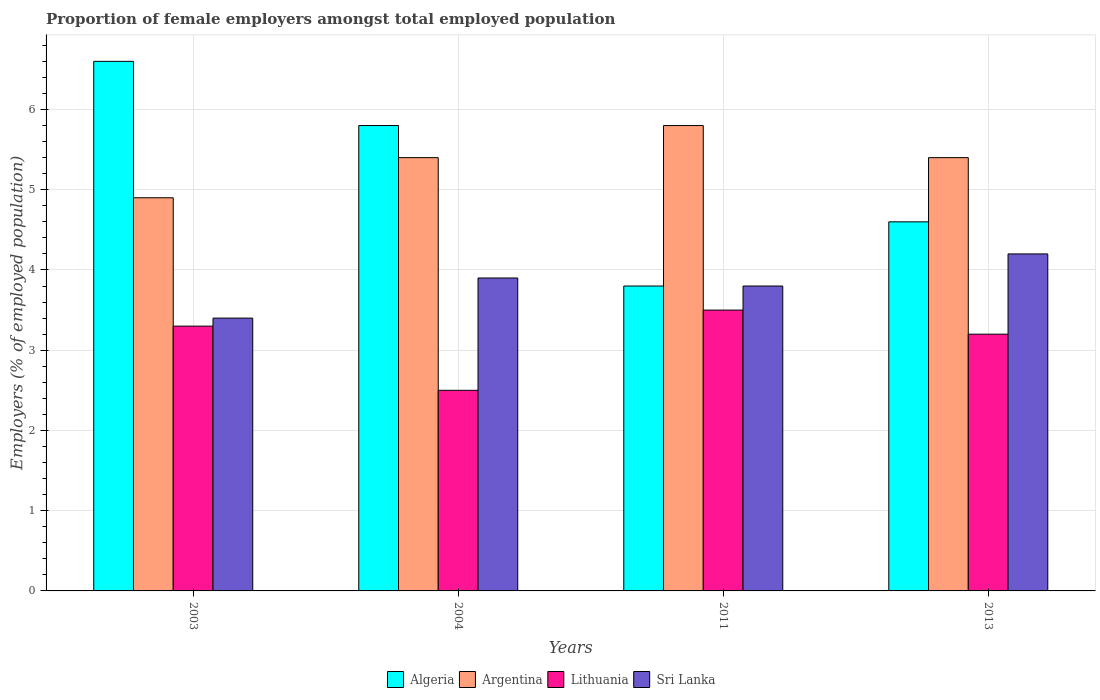How many different coloured bars are there?
Ensure brevity in your answer.  4. How many groups of bars are there?
Keep it short and to the point. 4. Are the number of bars per tick equal to the number of legend labels?
Your answer should be very brief. Yes. How many bars are there on the 4th tick from the left?
Give a very brief answer. 4. What is the label of the 4th group of bars from the left?
Your response must be concise. 2013. What is the proportion of female employers in Lithuania in 2011?
Give a very brief answer. 3.5. Across all years, what is the maximum proportion of female employers in Lithuania?
Make the answer very short. 3.5. Across all years, what is the minimum proportion of female employers in Argentina?
Give a very brief answer. 4.9. In which year was the proportion of female employers in Lithuania maximum?
Ensure brevity in your answer.  2011. In which year was the proportion of female employers in Sri Lanka minimum?
Offer a terse response. 2003. What is the total proportion of female employers in Algeria in the graph?
Your response must be concise. 20.8. What is the difference between the proportion of female employers in Lithuania in 2003 and that in 2004?
Ensure brevity in your answer.  0.8. What is the difference between the proportion of female employers in Lithuania in 2013 and the proportion of female employers in Algeria in 2004?
Make the answer very short. -2.6. What is the average proportion of female employers in Argentina per year?
Your answer should be compact. 5.38. In how many years, is the proportion of female employers in Algeria greater than 5 %?
Provide a short and direct response. 2. What is the ratio of the proportion of female employers in Sri Lanka in 2004 to that in 2011?
Your answer should be compact. 1.03. Is the proportion of female employers in Argentina in 2003 less than that in 2013?
Make the answer very short. Yes. Is the difference between the proportion of female employers in Sri Lanka in 2003 and 2013 greater than the difference between the proportion of female employers in Argentina in 2003 and 2013?
Offer a terse response. No. What is the difference between the highest and the second highest proportion of female employers in Algeria?
Provide a short and direct response. 0.8. Is the sum of the proportion of female employers in Sri Lanka in 2004 and 2013 greater than the maximum proportion of female employers in Argentina across all years?
Your answer should be very brief. Yes. Is it the case that in every year, the sum of the proportion of female employers in Argentina and proportion of female employers in Sri Lanka is greater than the sum of proportion of female employers in Algeria and proportion of female employers in Lithuania?
Provide a short and direct response. No. What does the 4th bar from the left in 2013 represents?
Your response must be concise. Sri Lanka. What does the 3rd bar from the right in 2011 represents?
Offer a terse response. Argentina. How many bars are there?
Give a very brief answer. 16. How many years are there in the graph?
Offer a terse response. 4. Are the values on the major ticks of Y-axis written in scientific E-notation?
Offer a terse response. No. Does the graph contain any zero values?
Give a very brief answer. No. Does the graph contain grids?
Offer a very short reply. Yes. Where does the legend appear in the graph?
Provide a succinct answer. Bottom center. How many legend labels are there?
Give a very brief answer. 4. How are the legend labels stacked?
Offer a very short reply. Horizontal. What is the title of the graph?
Give a very brief answer. Proportion of female employers amongst total employed population. What is the label or title of the X-axis?
Your answer should be compact. Years. What is the label or title of the Y-axis?
Give a very brief answer. Employers (% of employed population). What is the Employers (% of employed population) of Algeria in 2003?
Give a very brief answer. 6.6. What is the Employers (% of employed population) in Argentina in 2003?
Ensure brevity in your answer.  4.9. What is the Employers (% of employed population) in Lithuania in 2003?
Provide a short and direct response. 3.3. What is the Employers (% of employed population) in Sri Lanka in 2003?
Make the answer very short. 3.4. What is the Employers (% of employed population) of Algeria in 2004?
Keep it short and to the point. 5.8. What is the Employers (% of employed population) in Argentina in 2004?
Provide a succinct answer. 5.4. What is the Employers (% of employed population) in Sri Lanka in 2004?
Offer a very short reply. 3.9. What is the Employers (% of employed population) of Algeria in 2011?
Your answer should be very brief. 3.8. What is the Employers (% of employed population) of Argentina in 2011?
Provide a succinct answer. 5.8. What is the Employers (% of employed population) of Lithuania in 2011?
Your answer should be compact. 3.5. What is the Employers (% of employed population) of Sri Lanka in 2011?
Offer a terse response. 3.8. What is the Employers (% of employed population) of Algeria in 2013?
Your answer should be compact. 4.6. What is the Employers (% of employed population) in Argentina in 2013?
Ensure brevity in your answer.  5.4. What is the Employers (% of employed population) in Lithuania in 2013?
Offer a terse response. 3.2. What is the Employers (% of employed population) of Sri Lanka in 2013?
Provide a succinct answer. 4.2. Across all years, what is the maximum Employers (% of employed population) in Algeria?
Provide a succinct answer. 6.6. Across all years, what is the maximum Employers (% of employed population) of Argentina?
Offer a very short reply. 5.8. Across all years, what is the maximum Employers (% of employed population) in Sri Lanka?
Provide a succinct answer. 4.2. Across all years, what is the minimum Employers (% of employed population) of Algeria?
Your answer should be compact. 3.8. Across all years, what is the minimum Employers (% of employed population) in Argentina?
Your answer should be very brief. 4.9. Across all years, what is the minimum Employers (% of employed population) of Sri Lanka?
Keep it short and to the point. 3.4. What is the total Employers (% of employed population) of Algeria in the graph?
Offer a terse response. 20.8. What is the total Employers (% of employed population) of Lithuania in the graph?
Give a very brief answer. 12.5. What is the total Employers (% of employed population) of Sri Lanka in the graph?
Offer a very short reply. 15.3. What is the difference between the Employers (% of employed population) of Algeria in 2003 and that in 2004?
Offer a very short reply. 0.8. What is the difference between the Employers (% of employed population) in Argentina in 2003 and that in 2004?
Your response must be concise. -0.5. What is the difference between the Employers (% of employed population) of Lithuania in 2003 and that in 2004?
Offer a very short reply. 0.8. What is the difference between the Employers (% of employed population) in Algeria in 2003 and that in 2011?
Provide a succinct answer. 2.8. What is the difference between the Employers (% of employed population) in Lithuania in 2003 and that in 2011?
Provide a succinct answer. -0.2. What is the difference between the Employers (% of employed population) in Sri Lanka in 2003 and that in 2011?
Provide a short and direct response. -0.4. What is the difference between the Employers (% of employed population) of Algeria in 2003 and that in 2013?
Your response must be concise. 2. What is the difference between the Employers (% of employed population) of Argentina in 2003 and that in 2013?
Your answer should be very brief. -0.5. What is the difference between the Employers (% of employed population) in Argentina in 2004 and that in 2011?
Give a very brief answer. -0.4. What is the difference between the Employers (% of employed population) of Lithuania in 2004 and that in 2011?
Offer a very short reply. -1. What is the difference between the Employers (% of employed population) in Argentina in 2004 and that in 2013?
Keep it short and to the point. 0. What is the difference between the Employers (% of employed population) of Algeria in 2003 and the Employers (% of employed population) of Argentina in 2004?
Offer a very short reply. 1.2. What is the difference between the Employers (% of employed population) of Algeria in 2003 and the Employers (% of employed population) of Sri Lanka in 2004?
Make the answer very short. 2.7. What is the difference between the Employers (% of employed population) of Argentina in 2003 and the Employers (% of employed population) of Lithuania in 2004?
Provide a succinct answer. 2.4. What is the difference between the Employers (% of employed population) in Argentina in 2003 and the Employers (% of employed population) in Sri Lanka in 2004?
Offer a very short reply. 1. What is the difference between the Employers (% of employed population) in Algeria in 2003 and the Employers (% of employed population) in Lithuania in 2011?
Offer a terse response. 3.1. What is the difference between the Employers (% of employed population) of Algeria in 2003 and the Employers (% of employed population) of Sri Lanka in 2011?
Your answer should be very brief. 2.8. What is the difference between the Employers (% of employed population) of Argentina in 2003 and the Employers (% of employed population) of Lithuania in 2011?
Give a very brief answer. 1.4. What is the difference between the Employers (% of employed population) in Argentina in 2003 and the Employers (% of employed population) in Sri Lanka in 2011?
Give a very brief answer. 1.1. What is the difference between the Employers (% of employed population) in Algeria in 2003 and the Employers (% of employed population) in Lithuania in 2013?
Make the answer very short. 3.4. What is the difference between the Employers (% of employed population) in Argentina in 2003 and the Employers (% of employed population) in Sri Lanka in 2013?
Provide a short and direct response. 0.7. What is the difference between the Employers (% of employed population) of Algeria in 2004 and the Employers (% of employed population) of Argentina in 2011?
Provide a short and direct response. 0. What is the difference between the Employers (% of employed population) of Algeria in 2004 and the Employers (% of employed population) of Lithuania in 2011?
Give a very brief answer. 2.3. What is the difference between the Employers (% of employed population) in Algeria in 2004 and the Employers (% of employed population) in Sri Lanka in 2011?
Keep it short and to the point. 2. What is the difference between the Employers (% of employed population) in Argentina in 2004 and the Employers (% of employed population) in Lithuania in 2011?
Provide a succinct answer. 1.9. What is the difference between the Employers (% of employed population) in Algeria in 2004 and the Employers (% of employed population) in Argentina in 2013?
Offer a very short reply. 0.4. What is the difference between the Employers (% of employed population) of Algeria in 2004 and the Employers (% of employed population) of Lithuania in 2013?
Ensure brevity in your answer.  2.6. What is the difference between the Employers (% of employed population) in Algeria in 2004 and the Employers (% of employed population) in Sri Lanka in 2013?
Offer a terse response. 1.6. What is the difference between the Employers (% of employed population) of Argentina in 2004 and the Employers (% of employed population) of Lithuania in 2013?
Ensure brevity in your answer.  2.2. What is the difference between the Employers (% of employed population) of Algeria in 2011 and the Employers (% of employed population) of Argentina in 2013?
Your answer should be very brief. -1.6. What is the difference between the Employers (% of employed population) in Algeria in 2011 and the Employers (% of employed population) in Sri Lanka in 2013?
Make the answer very short. -0.4. What is the average Employers (% of employed population) in Argentina per year?
Your answer should be compact. 5.38. What is the average Employers (% of employed population) in Lithuania per year?
Give a very brief answer. 3.12. What is the average Employers (% of employed population) in Sri Lanka per year?
Your answer should be very brief. 3.83. In the year 2003, what is the difference between the Employers (% of employed population) of Algeria and Employers (% of employed population) of Lithuania?
Make the answer very short. 3.3. In the year 2003, what is the difference between the Employers (% of employed population) in Algeria and Employers (% of employed population) in Sri Lanka?
Give a very brief answer. 3.2. In the year 2003, what is the difference between the Employers (% of employed population) in Lithuania and Employers (% of employed population) in Sri Lanka?
Provide a succinct answer. -0.1. In the year 2004, what is the difference between the Employers (% of employed population) in Algeria and Employers (% of employed population) in Argentina?
Provide a short and direct response. 0.4. In the year 2004, what is the difference between the Employers (% of employed population) of Algeria and Employers (% of employed population) of Lithuania?
Your answer should be compact. 3.3. In the year 2004, what is the difference between the Employers (% of employed population) of Algeria and Employers (% of employed population) of Sri Lanka?
Give a very brief answer. 1.9. In the year 2004, what is the difference between the Employers (% of employed population) in Lithuania and Employers (% of employed population) in Sri Lanka?
Provide a short and direct response. -1.4. In the year 2011, what is the difference between the Employers (% of employed population) in Algeria and Employers (% of employed population) in Argentina?
Your response must be concise. -2. In the year 2011, what is the difference between the Employers (% of employed population) of Algeria and Employers (% of employed population) of Lithuania?
Your answer should be compact. 0.3. In the year 2011, what is the difference between the Employers (% of employed population) in Algeria and Employers (% of employed population) in Sri Lanka?
Provide a succinct answer. 0. In the year 2011, what is the difference between the Employers (% of employed population) in Argentina and Employers (% of employed population) in Lithuania?
Ensure brevity in your answer.  2.3. In the year 2011, what is the difference between the Employers (% of employed population) of Argentina and Employers (% of employed population) of Sri Lanka?
Keep it short and to the point. 2. In the year 2011, what is the difference between the Employers (% of employed population) in Lithuania and Employers (% of employed population) in Sri Lanka?
Offer a terse response. -0.3. In the year 2013, what is the difference between the Employers (% of employed population) of Algeria and Employers (% of employed population) of Argentina?
Your answer should be compact. -0.8. In the year 2013, what is the difference between the Employers (% of employed population) of Algeria and Employers (% of employed population) of Lithuania?
Keep it short and to the point. 1.4. In the year 2013, what is the difference between the Employers (% of employed population) of Lithuania and Employers (% of employed population) of Sri Lanka?
Provide a short and direct response. -1. What is the ratio of the Employers (% of employed population) in Algeria in 2003 to that in 2004?
Provide a short and direct response. 1.14. What is the ratio of the Employers (% of employed population) in Argentina in 2003 to that in 2004?
Your answer should be compact. 0.91. What is the ratio of the Employers (% of employed population) in Lithuania in 2003 to that in 2004?
Ensure brevity in your answer.  1.32. What is the ratio of the Employers (% of employed population) of Sri Lanka in 2003 to that in 2004?
Your answer should be compact. 0.87. What is the ratio of the Employers (% of employed population) in Algeria in 2003 to that in 2011?
Your response must be concise. 1.74. What is the ratio of the Employers (% of employed population) in Argentina in 2003 to that in 2011?
Provide a succinct answer. 0.84. What is the ratio of the Employers (% of employed population) of Lithuania in 2003 to that in 2011?
Your answer should be very brief. 0.94. What is the ratio of the Employers (% of employed population) in Sri Lanka in 2003 to that in 2011?
Provide a short and direct response. 0.89. What is the ratio of the Employers (% of employed population) in Algeria in 2003 to that in 2013?
Make the answer very short. 1.43. What is the ratio of the Employers (% of employed population) in Argentina in 2003 to that in 2013?
Your response must be concise. 0.91. What is the ratio of the Employers (% of employed population) in Lithuania in 2003 to that in 2013?
Offer a very short reply. 1.03. What is the ratio of the Employers (% of employed population) of Sri Lanka in 2003 to that in 2013?
Offer a terse response. 0.81. What is the ratio of the Employers (% of employed population) in Algeria in 2004 to that in 2011?
Provide a succinct answer. 1.53. What is the ratio of the Employers (% of employed population) of Argentina in 2004 to that in 2011?
Make the answer very short. 0.93. What is the ratio of the Employers (% of employed population) of Lithuania in 2004 to that in 2011?
Provide a succinct answer. 0.71. What is the ratio of the Employers (% of employed population) in Sri Lanka in 2004 to that in 2011?
Make the answer very short. 1.03. What is the ratio of the Employers (% of employed population) in Algeria in 2004 to that in 2013?
Make the answer very short. 1.26. What is the ratio of the Employers (% of employed population) in Argentina in 2004 to that in 2013?
Ensure brevity in your answer.  1. What is the ratio of the Employers (% of employed population) in Lithuania in 2004 to that in 2013?
Make the answer very short. 0.78. What is the ratio of the Employers (% of employed population) in Sri Lanka in 2004 to that in 2013?
Your answer should be very brief. 0.93. What is the ratio of the Employers (% of employed population) of Algeria in 2011 to that in 2013?
Keep it short and to the point. 0.83. What is the ratio of the Employers (% of employed population) of Argentina in 2011 to that in 2013?
Offer a terse response. 1.07. What is the ratio of the Employers (% of employed population) of Lithuania in 2011 to that in 2013?
Your response must be concise. 1.09. What is the ratio of the Employers (% of employed population) of Sri Lanka in 2011 to that in 2013?
Provide a short and direct response. 0.9. What is the difference between the highest and the second highest Employers (% of employed population) in Algeria?
Offer a very short reply. 0.8. What is the difference between the highest and the second highest Employers (% of employed population) in Argentina?
Your response must be concise. 0.4. What is the difference between the highest and the second highest Employers (% of employed population) of Lithuania?
Give a very brief answer. 0.2. What is the difference between the highest and the lowest Employers (% of employed population) of Algeria?
Keep it short and to the point. 2.8. What is the difference between the highest and the lowest Employers (% of employed population) in Argentina?
Your answer should be very brief. 0.9. 